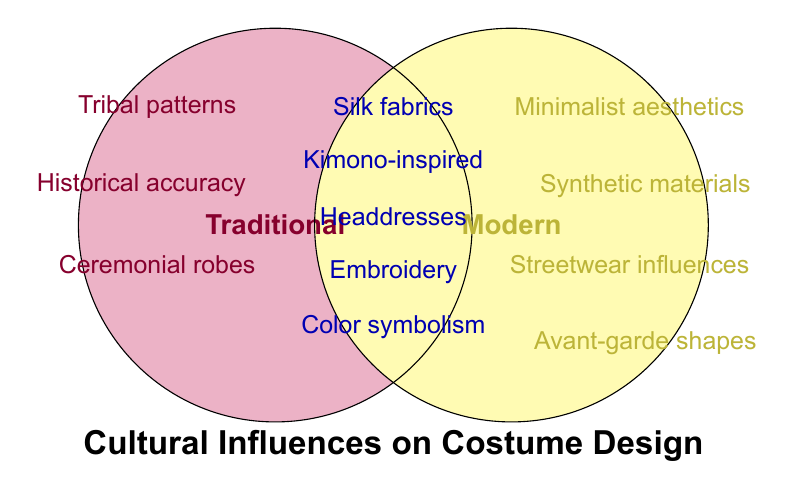What is the title of the figure? The title is located at the bottom of the figure. It is written in bold, large font.
Answer: Cultural Influences on Costume Design Which elements are present in both traditional and modern costume designs? These elements are found in the overlapping section of the two circles.
Answer: Silk fabrics, Kimono-inspired designs, Headdresses, Embroidery techniques, Color symbolism Which elements are unique to traditional costume designs? These elements are located completely inside the "Traditional" circle without overlapping into the "Modern" circle.
Answer: Tribal patterns, Historical accuracy, Ceremonial robes Which elements are unique to Modern costume designs? These elements are located completely inside the "Modern" circle without overlapping into the "Traditional" circle.
Answer: Minimalist aesthetics, Synthetic materials, Streetwear influences, Avant-garde shapes How many elements are influenced by both traditional and modern designs? Count the items listed in the overlapping section of the circles. There are five items.
Answer: 5 Are any elements influenced by cultural, traditional, and modern factors? Since the diagram only shows two aspects (traditional and modern), any element influenced in all would be in the center. However, no such triple overlap is shown.
Answer: No Which section has more unique elements, traditional or modern? Compare the number of unique elements listed inside each circle. Traditional has three, and modern has four.
Answer: Modern How do the traditional influences typically differ from the modern influences in costume design according to the figure? Traditional influences include elements like Historical accuracy, Ceremonial robes, and Tribal patterns, while modern influences include Minimalist aesthetics, Synthetic materials, Streetwear influences, and Avant-garde shapes.
Answer: Traditional focuses on heritage elements, modern incorporates innovative and minimalist trends 